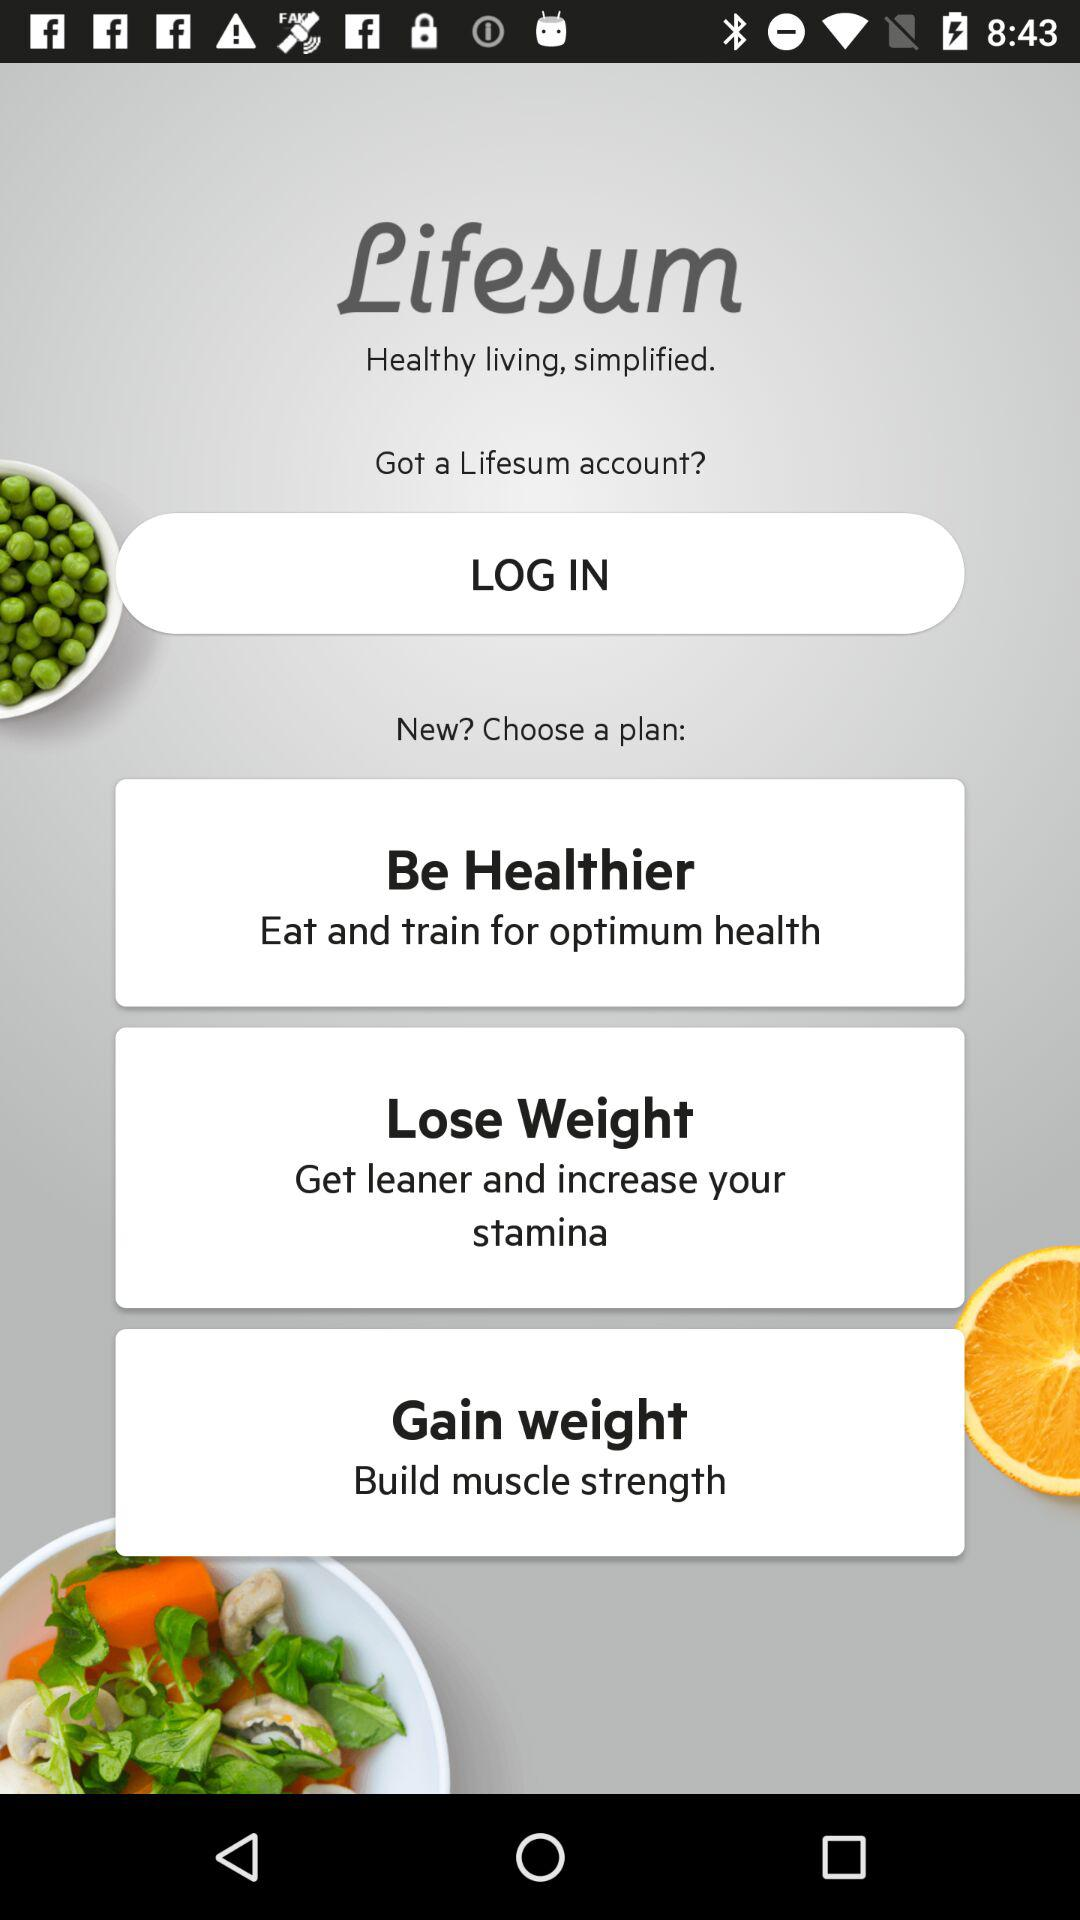By which plan can muscle strength be built? The plan that can build muscle strength is "Gain weight". 